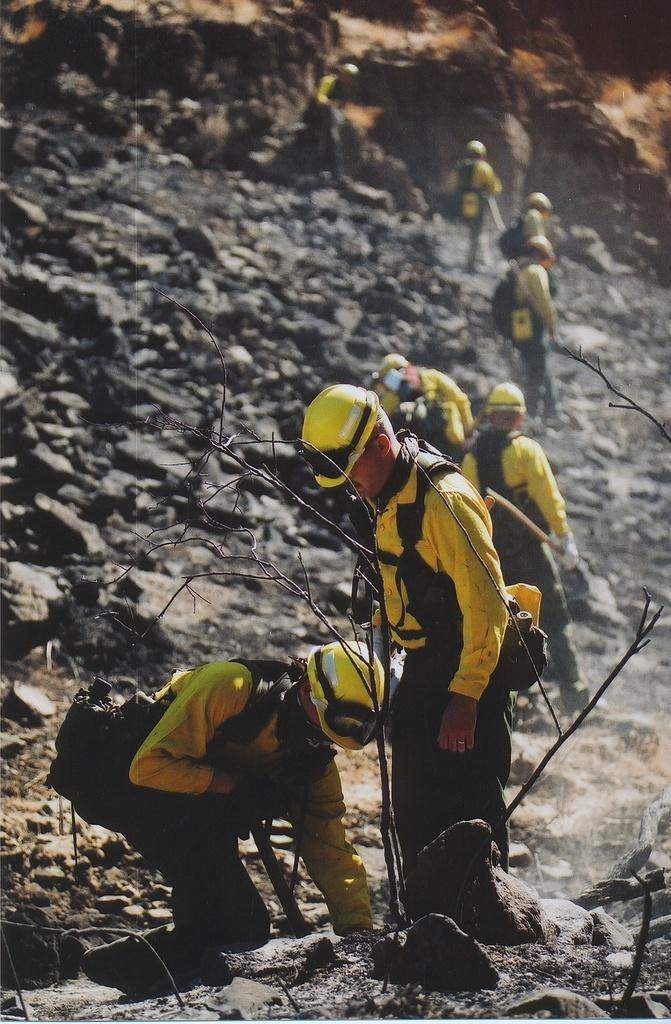How many people are in the image? There is a group of people in the image. What are the people wearing on their heads? The people are wearing helmets. What type of natural elements can be seen in the image? There are branches and rocks in the image. What type of rod is being used by the people in the image? There is no rod visible in the image; the people are wearing helmets. What kind of pets are accompanying the people in the image? There are no pets present in the image; the focus is on the group of people wearing helmets. 